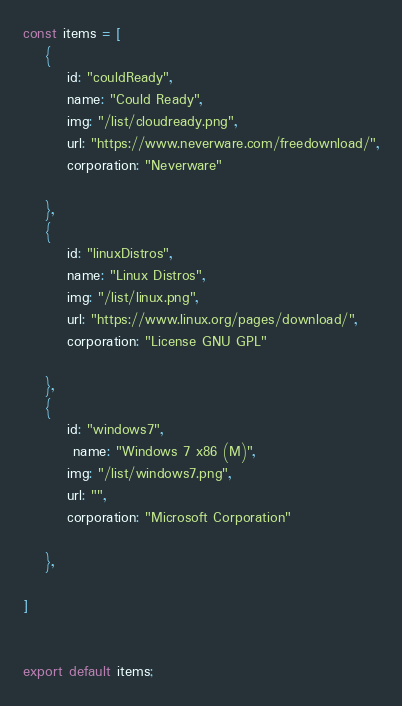Convert code to text. <code><loc_0><loc_0><loc_500><loc_500><_JavaScript_>const items = [
    {
        id: "couldReady",
        name: "Could Ready",
        img: "/list/cloudready.png",
        url: "https://www.neverware.com/freedownload/",
        corporation: "Neverware"
        
    },
    {
        id: "linuxDistros",
        name: "Linux Distros",
        img: "/list/linux.png",
        url: "https://www.linux.org/pages/download/",
        corporation: "License GNU GPL"
        
    },
    {
        id: "windows7",
         name: "Windows 7 x86 (M)",
        img: "/list/windows7.png",
        url: "",
        corporation: "Microsoft Corporation"
        
    },

]


export default items;</code> 